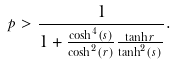<formula> <loc_0><loc_0><loc_500><loc_500>p > \frac { 1 } { 1 + \frac { \cosh ^ { 4 } ( s ) } { \cosh ^ { 2 } ( r ) } \frac { \tanh r } { \tanh ^ { 2 } ( s ) } } .</formula> 